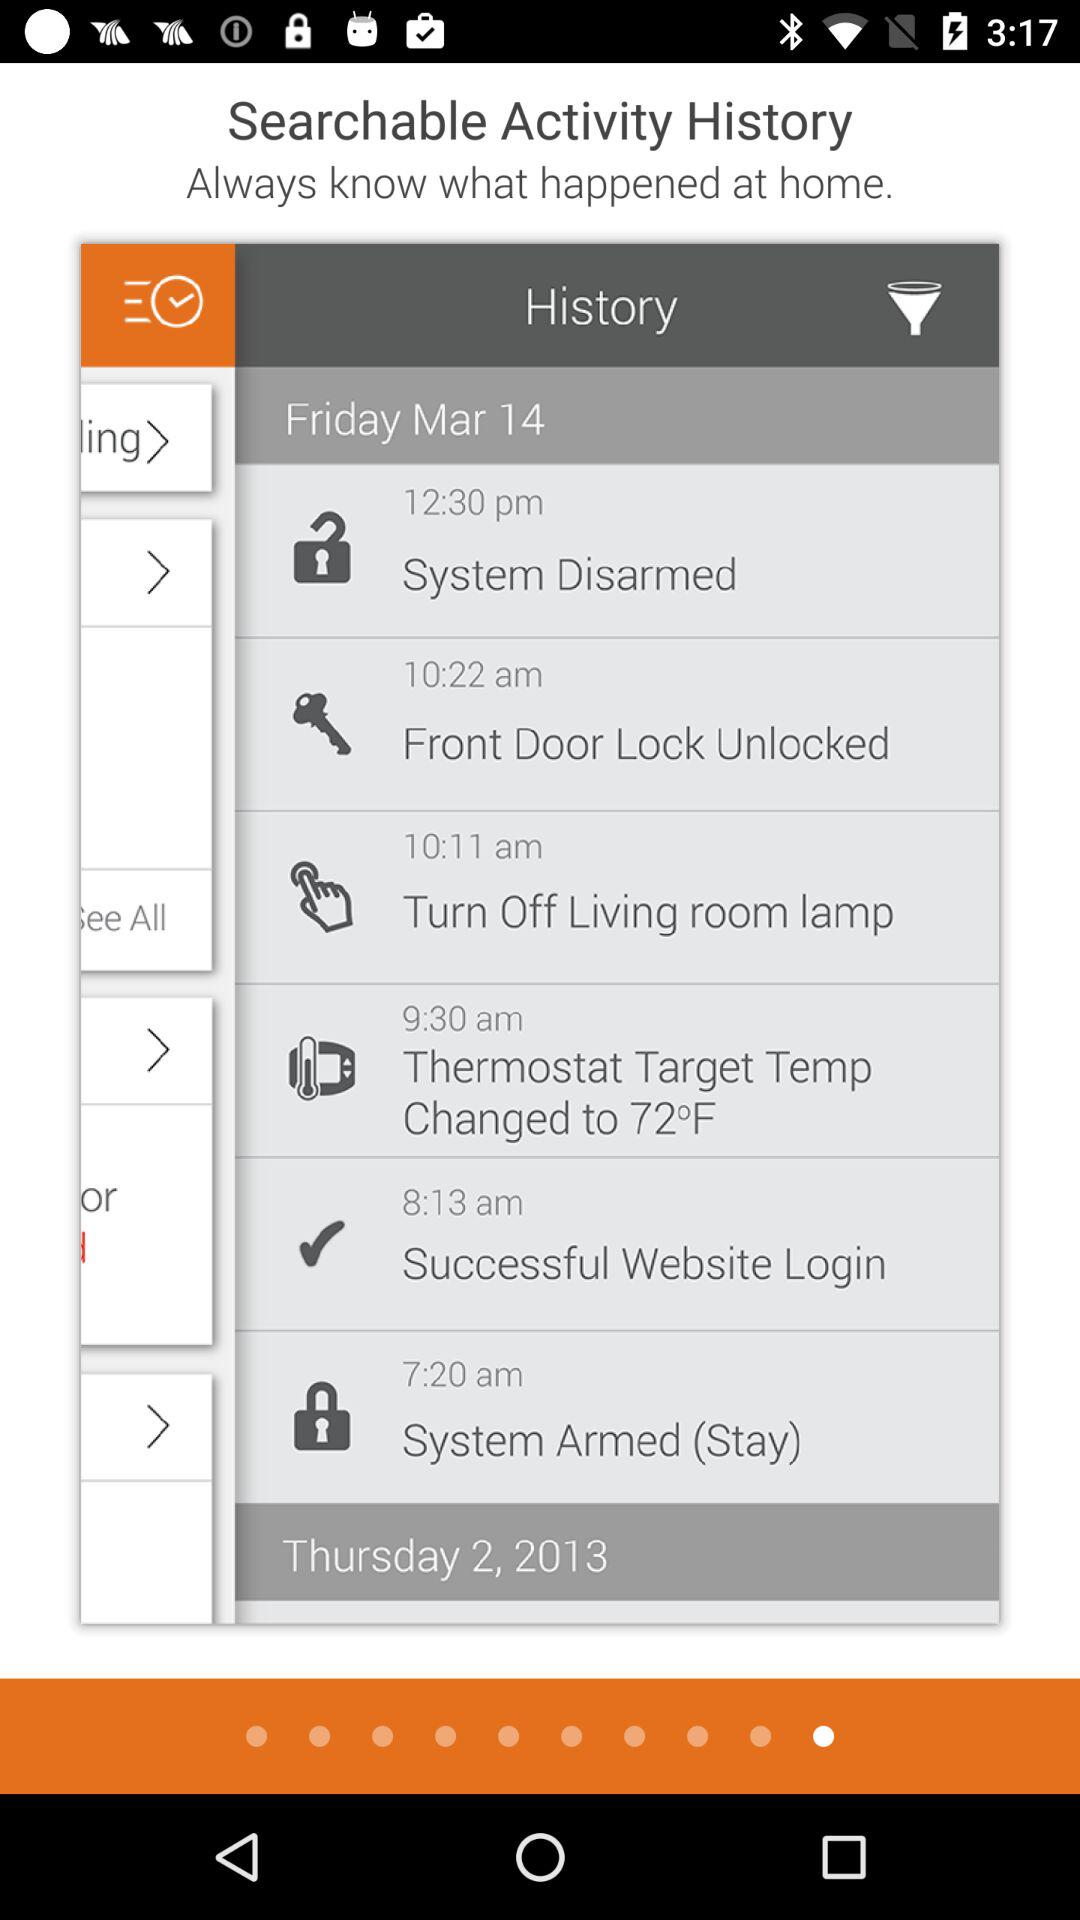At what time was the system armed? The system was armed at 7:20 a.m. 